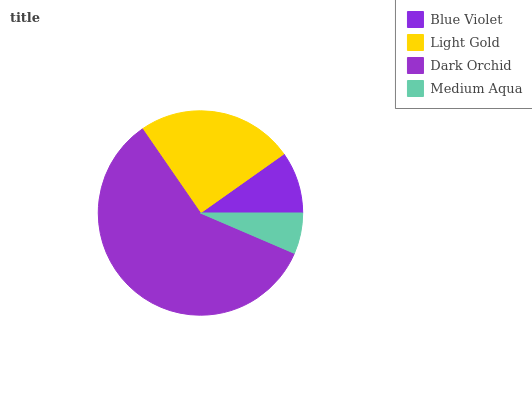Is Medium Aqua the minimum?
Answer yes or no. Yes. Is Dark Orchid the maximum?
Answer yes or no. Yes. Is Light Gold the minimum?
Answer yes or no. No. Is Light Gold the maximum?
Answer yes or no. No. Is Light Gold greater than Blue Violet?
Answer yes or no. Yes. Is Blue Violet less than Light Gold?
Answer yes or no. Yes. Is Blue Violet greater than Light Gold?
Answer yes or no. No. Is Light Gold less than Blue Violet?
Answer yes or no. No. Is Light Gold the high median?
Answer yes or no. Yes. Is Blue Violet the low median?
Answer yes or no. Yes. Is Dark Orchid the high median?
Answer yes or no. No. Is Dark Orchid the low median?
Answer yes or no. No. 